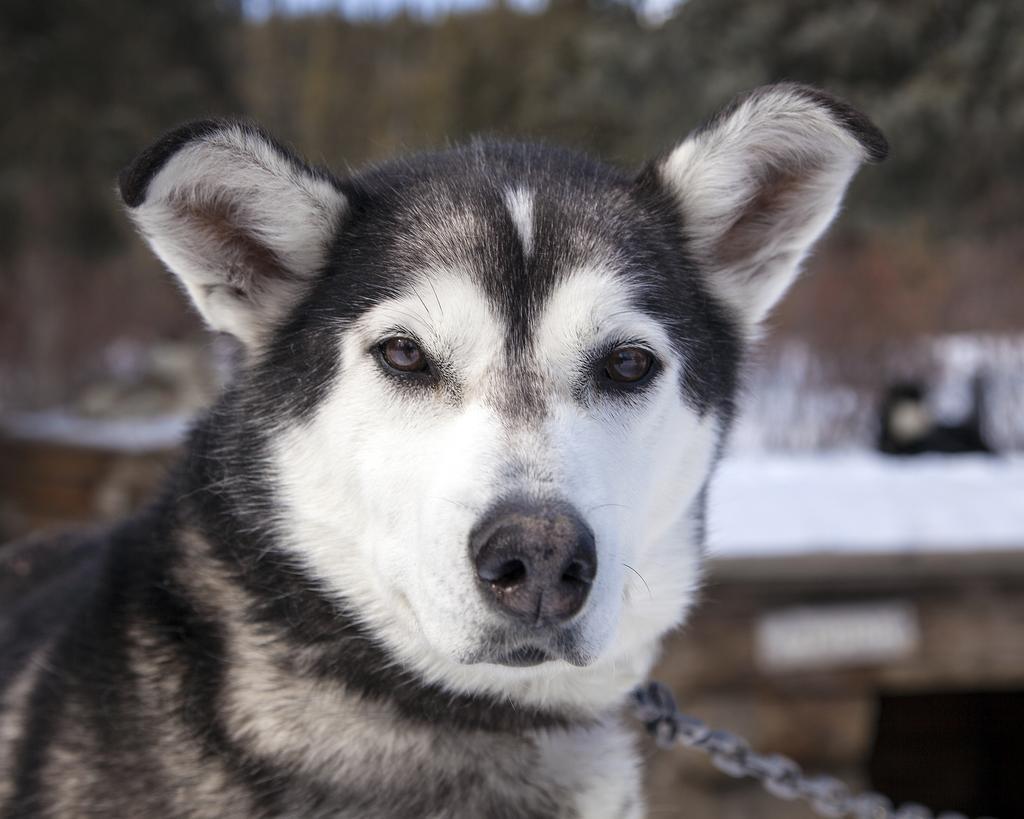In one or two sentences, can you explain what this image depicts? In this image, I can see a dog. At the bottom of the image, this is an iron chain. The background looks blurry. 